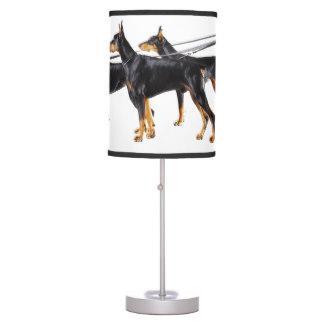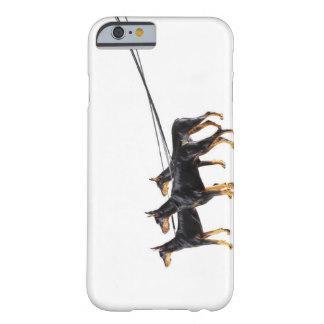The first image is the image on the left, the second image is the image on the right. Evaluate the accuracy of this statement regarding the images: "there is a keychain with3 dogs on it". Is it true? Answer yes or no. No. The first image is the image on the left, the second image is the image on the right. Given the left and right images, does the statement "One image shows a silver keychain featuring a dog theme, and the other image contains a white rectangle with a dog theme." hold true? Answer yes or no. No. 